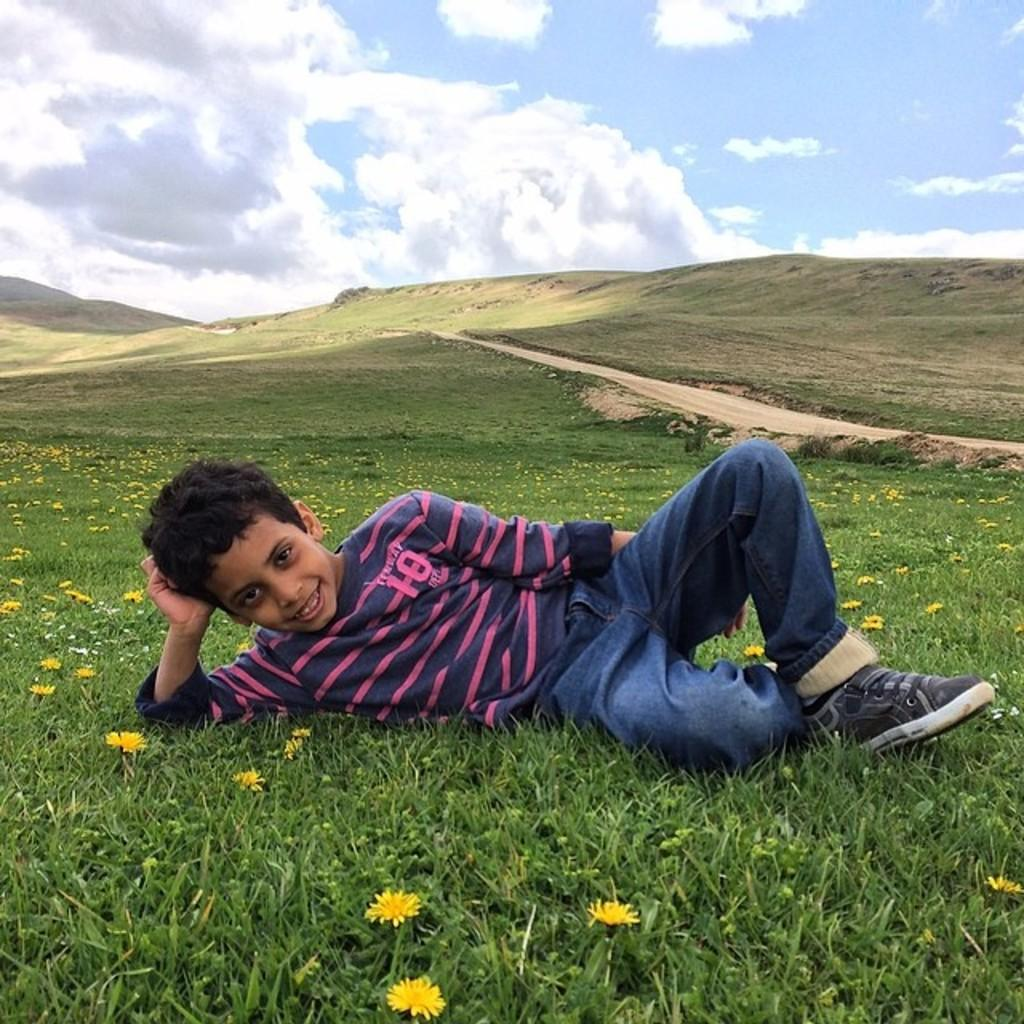Who is in the picture? There is a boy in the picture. What is the boy wearing? The boy is wearing a blue and pink t-shirt. What is the boy doing in the picture? The boy is lying on the grass and giving a pose into the camera. What expression does the boy have? The boy is smiling. What can be seen in the background of the picture? There is a hilly area in the background of the picture, and it is full of grass. Can you see the seashore in the background of the image? No, there is no seashore visible in the image; it features a hilly area full of grass. What type of beam is supporting the boy's pose in the image? There is no beam present in the image; the boy is lying on the grass and giving a pose into the camera. 